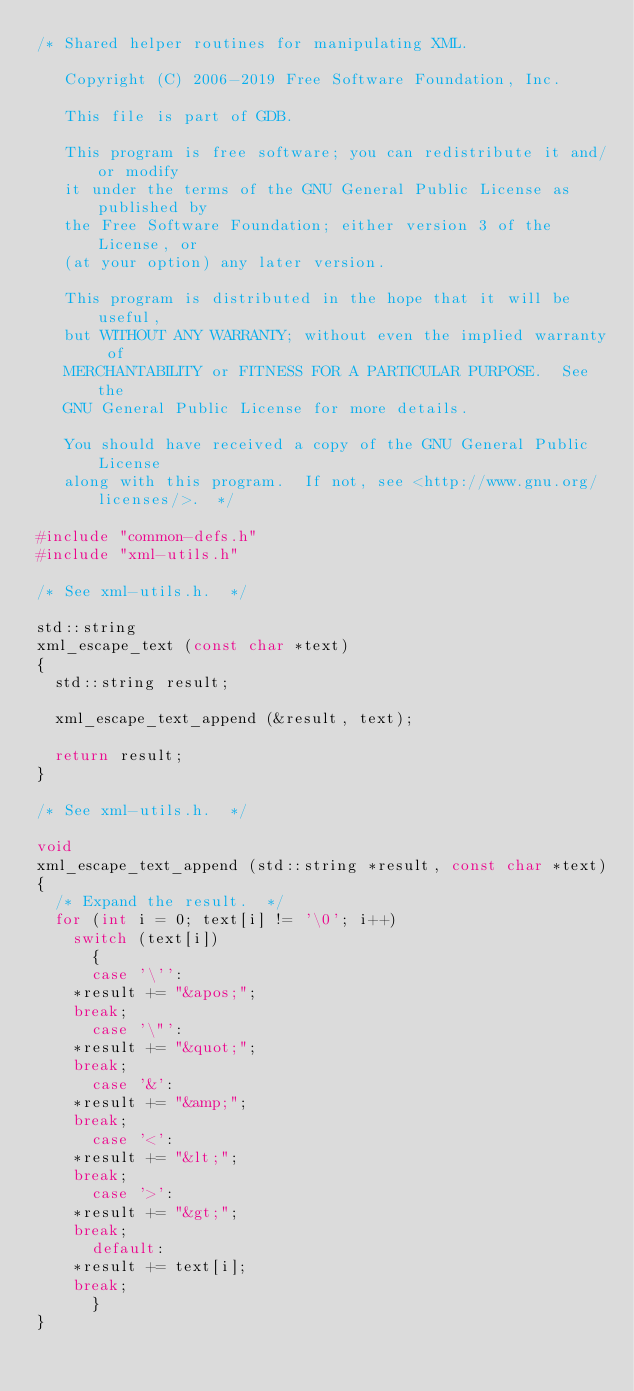Convert code to text. <code><loc_0><loc_0><loc_500><loc_500><_C_>/* Shared helper routines for manipulating XML.

   Copyright (C) 2006-2019 Free Software Foundation, Inc.

   This file is part of GDB.

   This program is free software; you can redistribute it and/or modify
   it under the terms of the GNU General Public License as published by
   the Free Software Foundation; either version 3 of the License, or
   (at your option) any later version.

   This program is distributed in the hope that it will be useful,
   but WITHOUT ANY WARRANTY; without even the implied warranty of
   MERCHANTABILITY or FITNESS FOR A PARTICULAR PURPOSE.  See the
   GNU General Public License for more details.

   You should have received a copy of the GNU General Public License
   along with this program.  If not, see <http://www.gnu.org/licenses/>.  */

#include "common-defs.h"
#include "xml-utils.h"

/* See xml-utils.h.  */

std::string
xml_escape_text (const char *text)
{
  std::string result;

  xml_escape_text_append (&result, text);

  return result;
}

/* See xml-utils.h.  */

void
xml_escape_text_append (std::string *result, const char *text)
{
  /* Expand the result.  */
  for (int i = 0; text[i] != '\0'; i++)
    switch (text[i])
      {
      case '\'':
	*result += "&apos;";
	break;
      case '\"':
	*result += "&quot;";
	break;
      case '&':
	*result += "&amp;";
	break;
      case '<':
	*result += "&lt;";
	break;
      case '>':
	*result += "&gt;";
	break;
      default:
	*result += text[i];
	break;
      }
}
</code> 